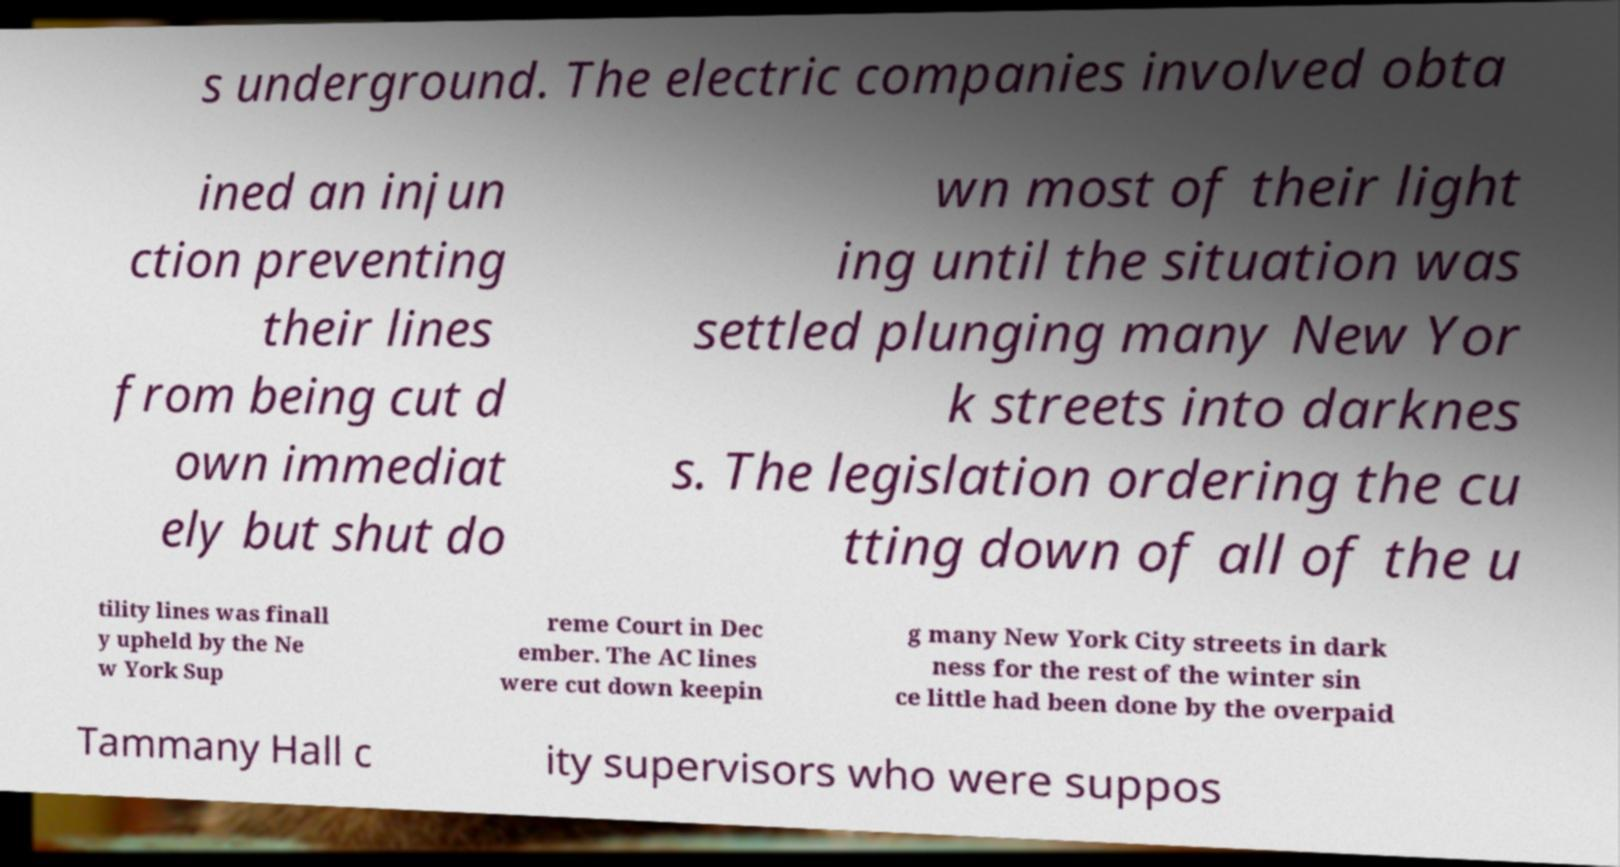Could you extract and type out the text from this image? s underground. The electric companies involved obta ined an injun ction preventing their lines from being cut d own immediat ely but shut do wn most of their light ing until the situation was settled plunging many New Yor k streets into darknes s. The legislation ordering the cu tting down of all of the u tility lines was finall y upheld by the Ne w York Sup reme Court in Dec ember. The AC lines were cut down keepin g many New York City streets in dark ness for the rest of the winter sin ce little had been done by the overpaid Tammany Hall c ity supervisors who were suppos 